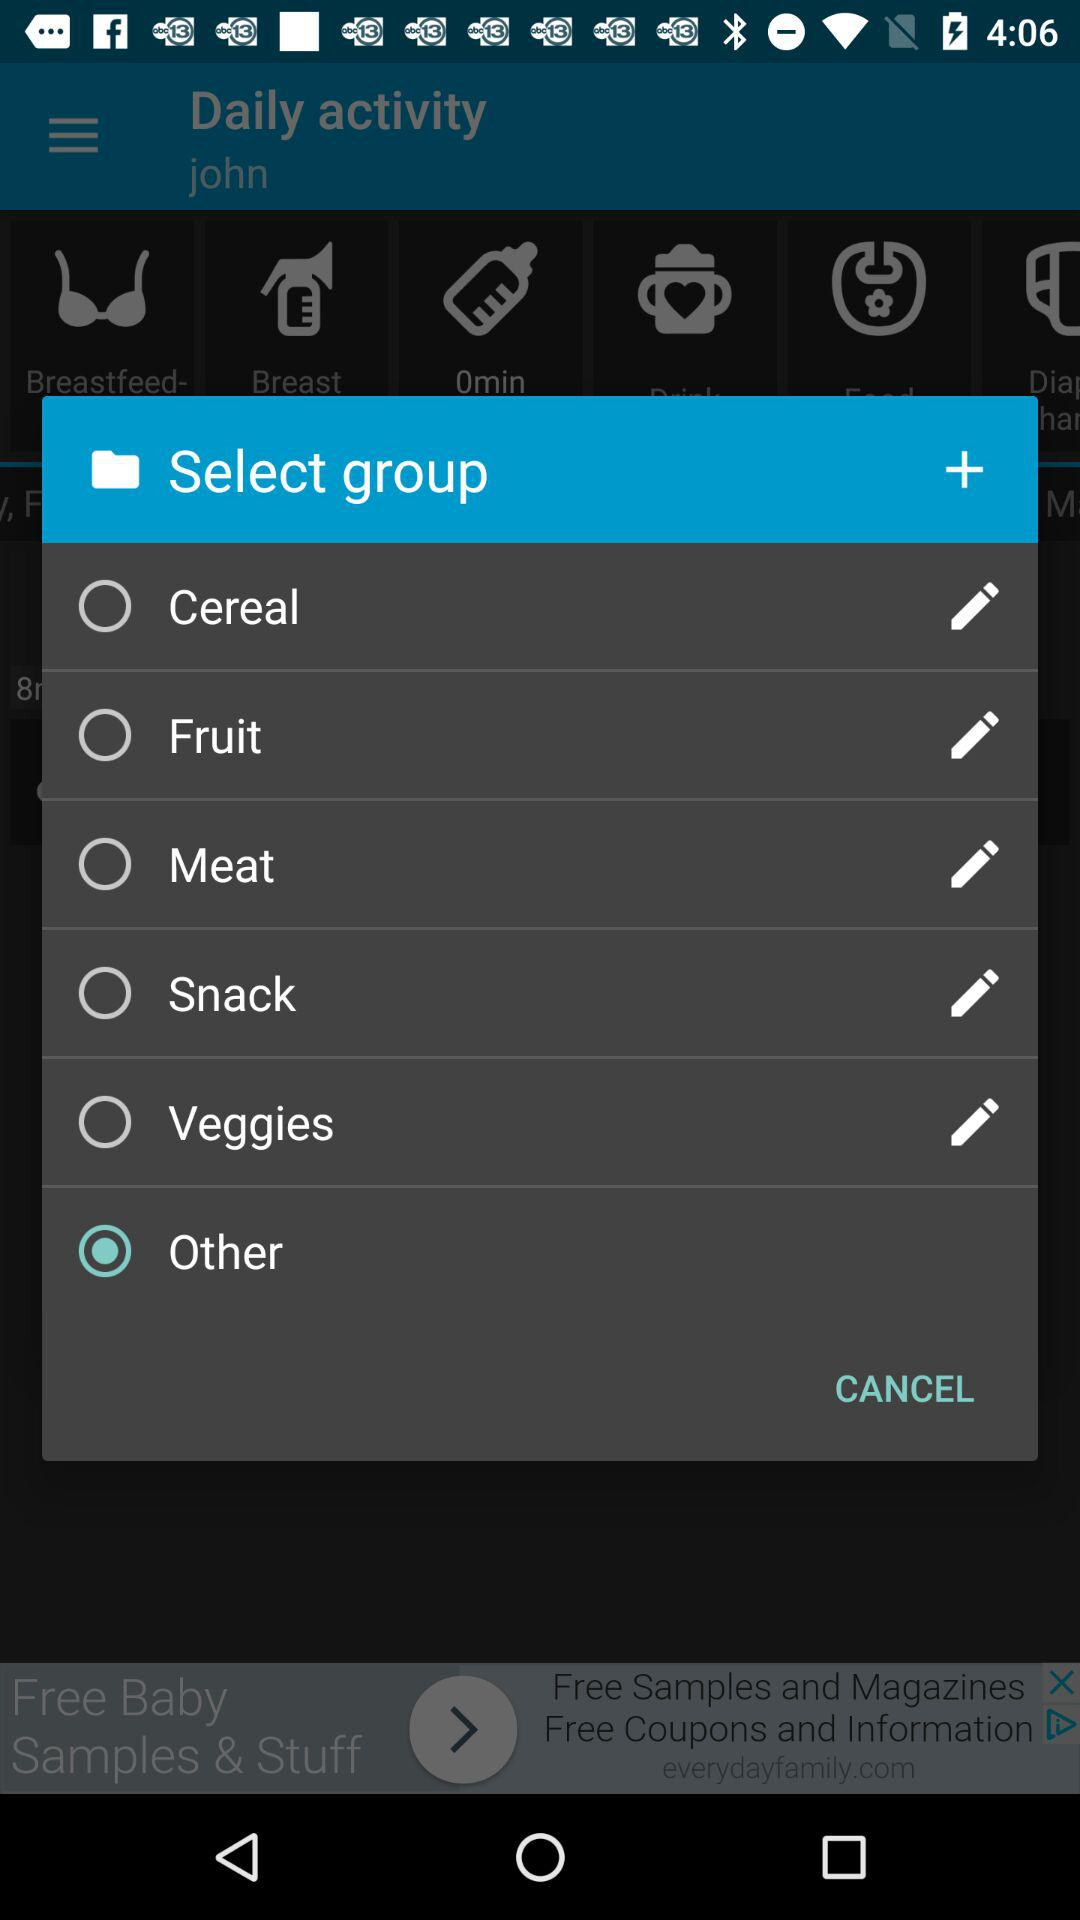Which option is selected? The selected option is "Other". 